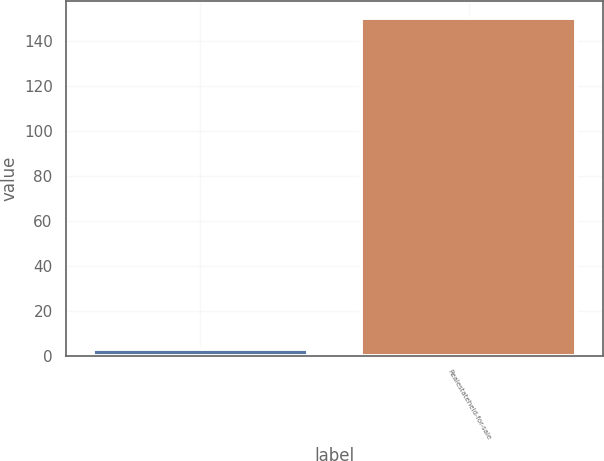<chart> <loc_0><loc_0><loc_500><loc_500><bar_chart><ecel><fcel>Realestateheld-for-sale<nl><fcel>3<fcel>150.4<nl></chart> 